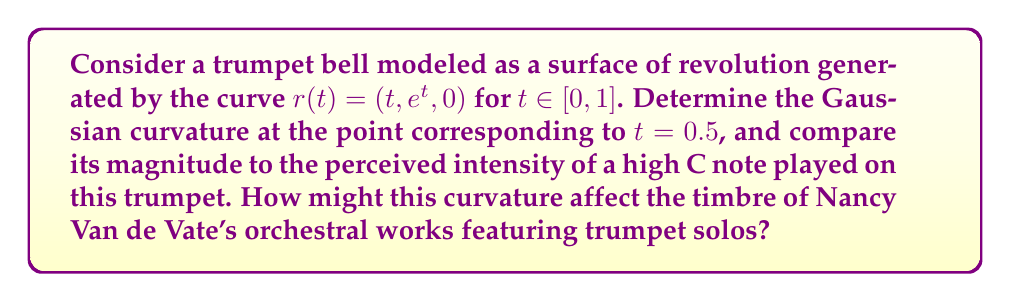Can you answer this question? To find the Gaussian curvature, we'll follow these steps:

1) The surface of revolution is given by:
   $$X(t, \theta) = (t, e^t \cos\theta, e^t \sin\theta)$$

2) Calculate the first fundamental form coefficients:
   $$E = \left\langle X_t, X_t \right\rangle = 1 + (e^t)^2$$
   $$F = \left\langle X_t, X_\theta \right\rangle = 0$$
   $$G = \left\langle X_\theta, X_\theta \right\rangle = (e^t)^2$$

3) Calculate the second fundamental form coefficients:
   $$\mathbf{n} = \frac{X_t \times X_\theta}{|X_t \times X_\theta|} = \frac{(-e^t, \cos\theta, \sin\theta)}{\sqrt{1 + (e^t)^2}}$$
   
   $$L = \left\langle X_{tt}, \mathbf{n} \right\rangle = \frac{-e^t}{\sqrt{1 + (e^t)^2}}$$
   $$M = \left\langle X_{t\theta}, \mathbf{n} \right\rangle = 0$$
   $$N = \left\langle X_{\theta\theta}, \mathbf{n} \right\rangle = \frac{e^t}{\sqrt{1 + (e^t)^2}}$$

4) The Gaussian curvature is given by:
   $$K = \frac{LN - M^2}{EG - F^2} = \frac{-e^t}{(1 + (e^t)^2)^2}$$

5) At $t = 0.5$:
   $$K = \frac{-e^{0.5}}{(1 + (e^{0.5})^2)^2} \approx -0.2008$$

The negative curvature indicates that the trumpet bell is shaped like a saddle at this point, which contributes to the instrument's ability to project sound. This curvature affects the resonance and overtones of the trumpet, potentially influencing the timbre of Van de Vate's compositions featuring trumpet solos.
Answer: $K \approx -0.2008$ at $t = 0.5$ 